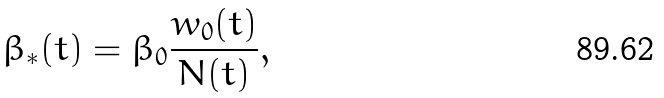<formula> <loc_0><loc_0><loc_500><loc_500>\beta _ { \ast } ( t ) = \beta _ { 0 } \frac { w _ { 0 } ( t ) } { N ( t ) } ,</formula> 